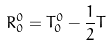Convert formula to latex. <formula><loc_0><loc_0><loc_500><loc_500>R _ { 0 } ^ { 0 } = T _ { 0 } ^ { 0 } - \frac { 1 } { 2 } T</formula> 